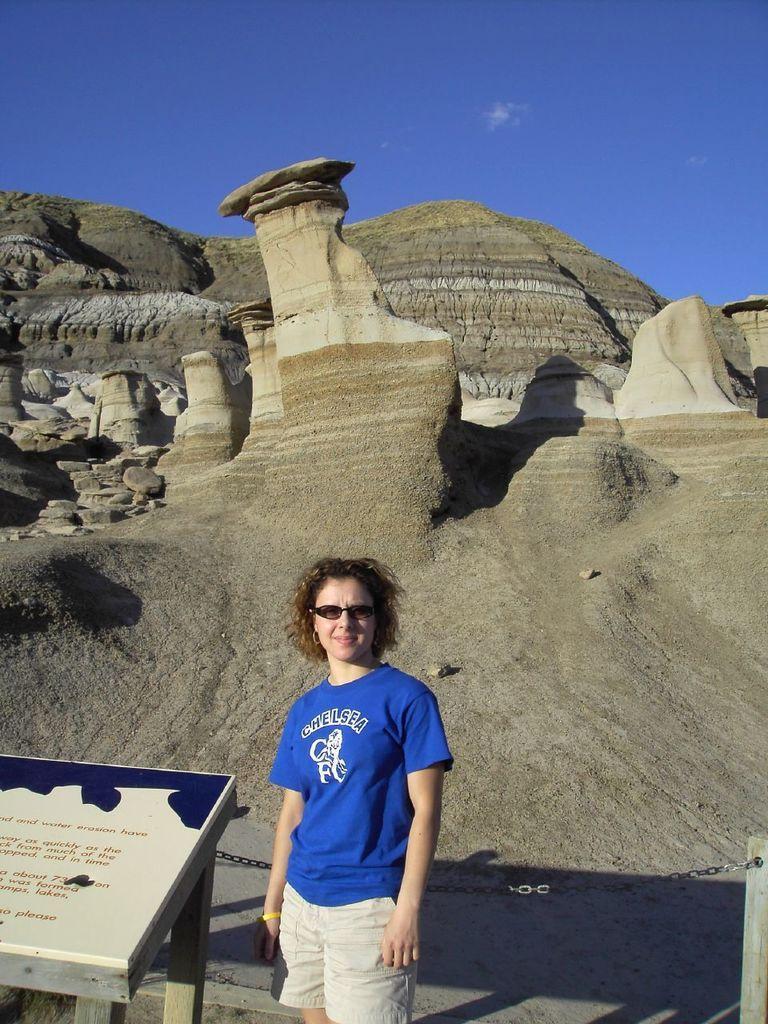Could you give a brief overview of what you see in this image? In this image we can see a lady wearing goggles. Near to her there is a stand with a board. On the board there is text. In the back there are rocks. Also there is sky with clouds. 